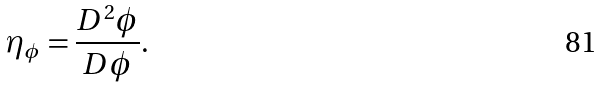Convert formula to latex. <formula><loc_0><loc_0><loc_500><loc_500>\eta _ { \phi } = \frac { D ^ { 2 } \phi } { D \phi } .</formula> 